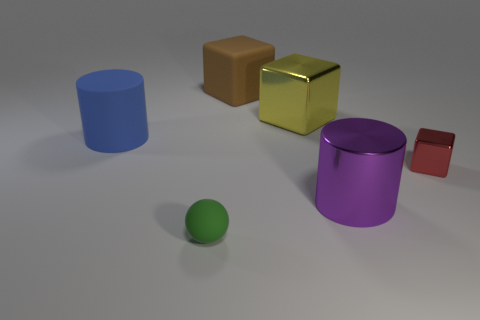Add 4 tiny purple cylinders. How many objects exist? 10 Subtract all spheres. How many objects are left? 5 Subtract 1 purple cylinders. How many objects are left? 5 Subtract all big brown rubber blocks. Subtract all green matte objects. How many objects are left? 4 Add 4 large blue objects. How many large blue objects are left? 5 Add 1 large red rubber spheres. How many large red rubber spheres exist? 1 